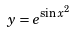<formula> <loc_0><loc_0><loc_500><loc_500>y = e ^ { \sin x ^ { 2 } }</formula> 